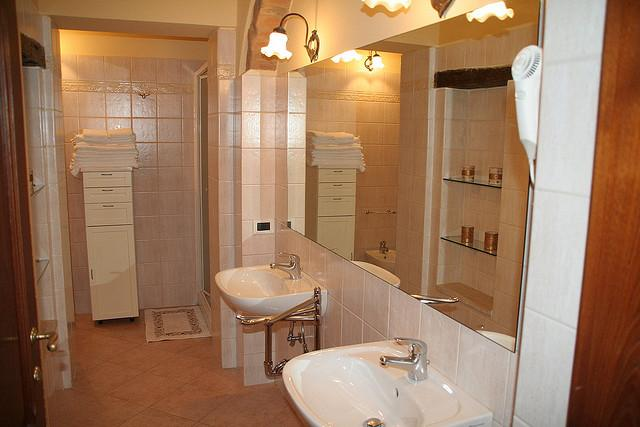What typical bathroom item is integrated into the wall that normally is free standing?

Choices:
A) plumbing
B) hair dryer
C) mirror
D) sink hair dryer 